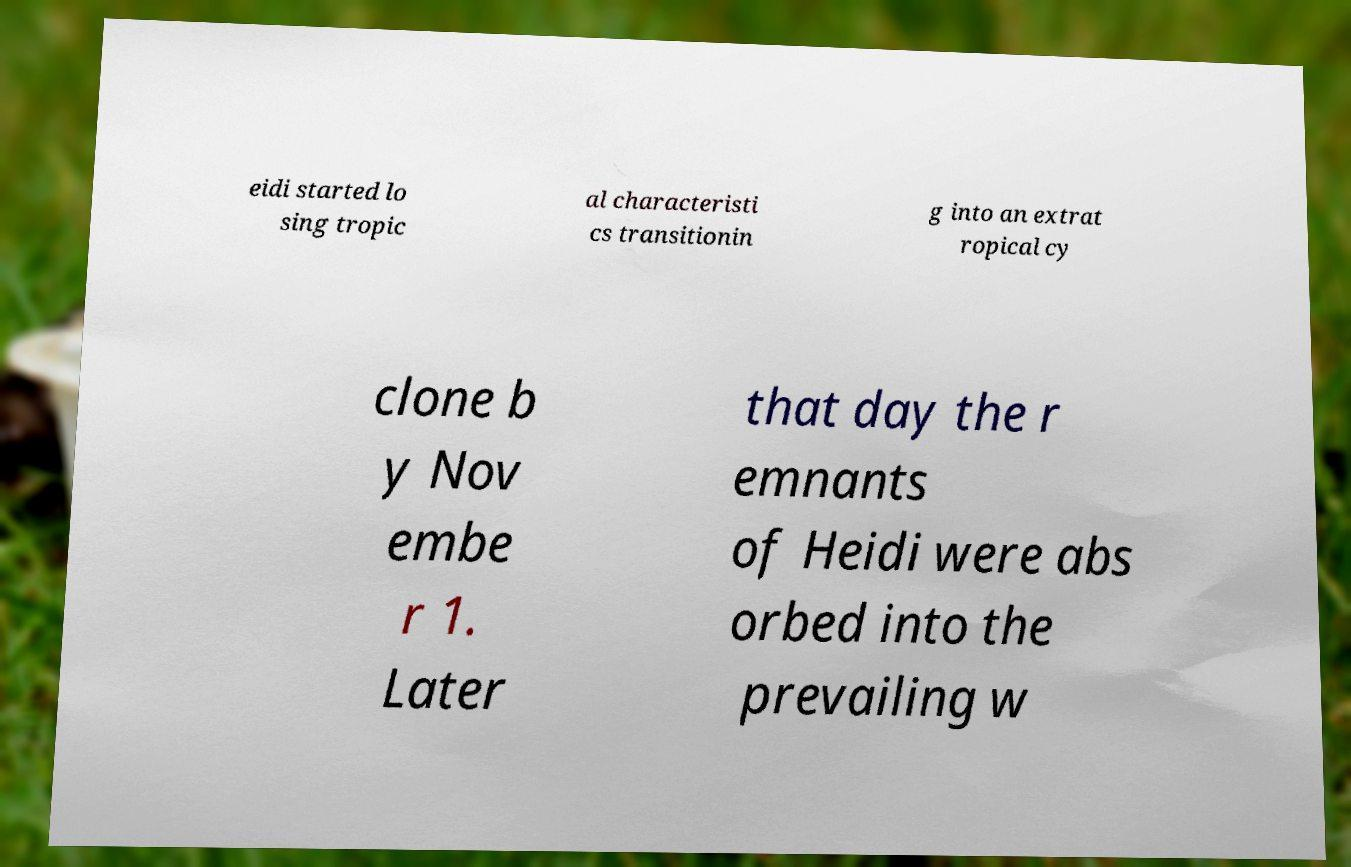Could you extract and type out the text from this image? eidi started lo sing tropic al characteristi cs transitionin g into an extrat ropical cy clone b y Nov embe r 1. Later that day the r emnants of Heidi were abs orbed into the prevailing w 